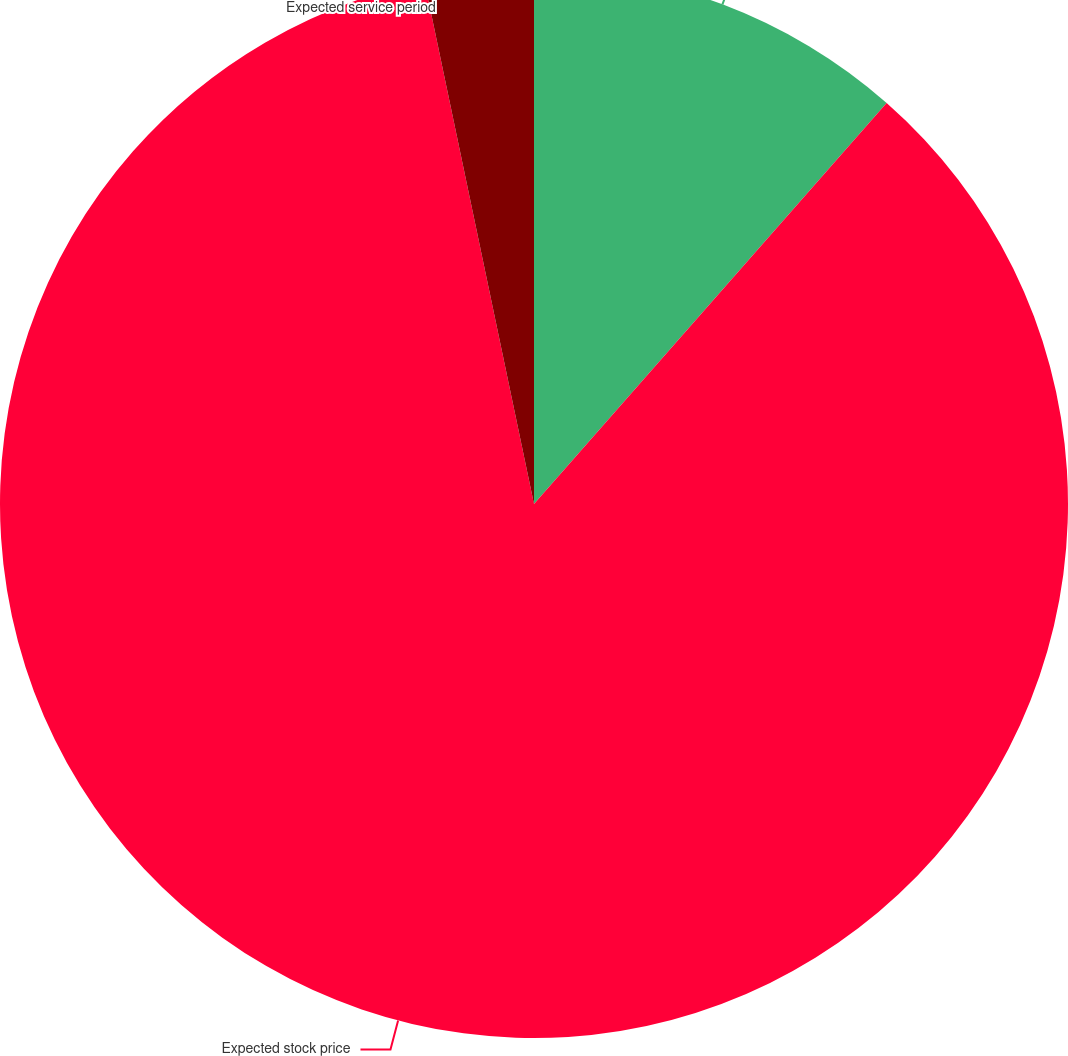Convert chart to OTSL. <chart><loc_0><loc_0><loc_500><loc_500><pie_chart><fcel>Risk-free interest rate<fcel>Expected stock price<fcel>Expected service period<nl><fcel>11.48%<fcel>85.23%<fcel>3.29%<nl></chart> 